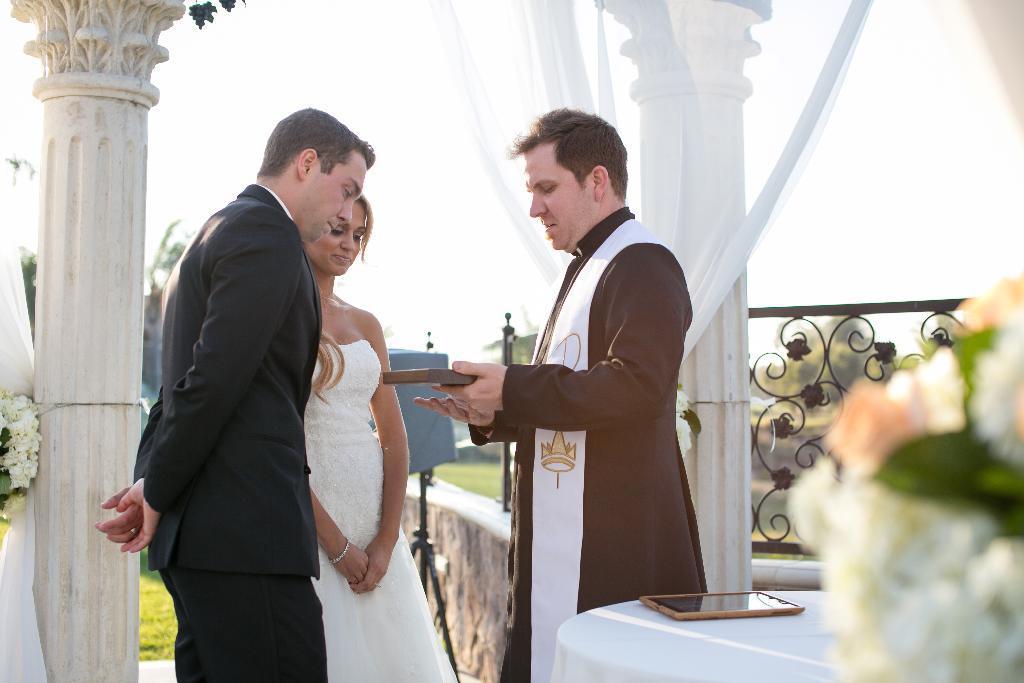Can you describe this image briefly? In this picture we can see a person holding an object in his hand. We can see a man and a woman standing on the left side. There are a few flowers on the right and left side of the image. We can see some pillars, white curtains and railing is visible on the right side. There is a wall at the back. Some grass is visible on the ground. Few trees are visible in the background. 